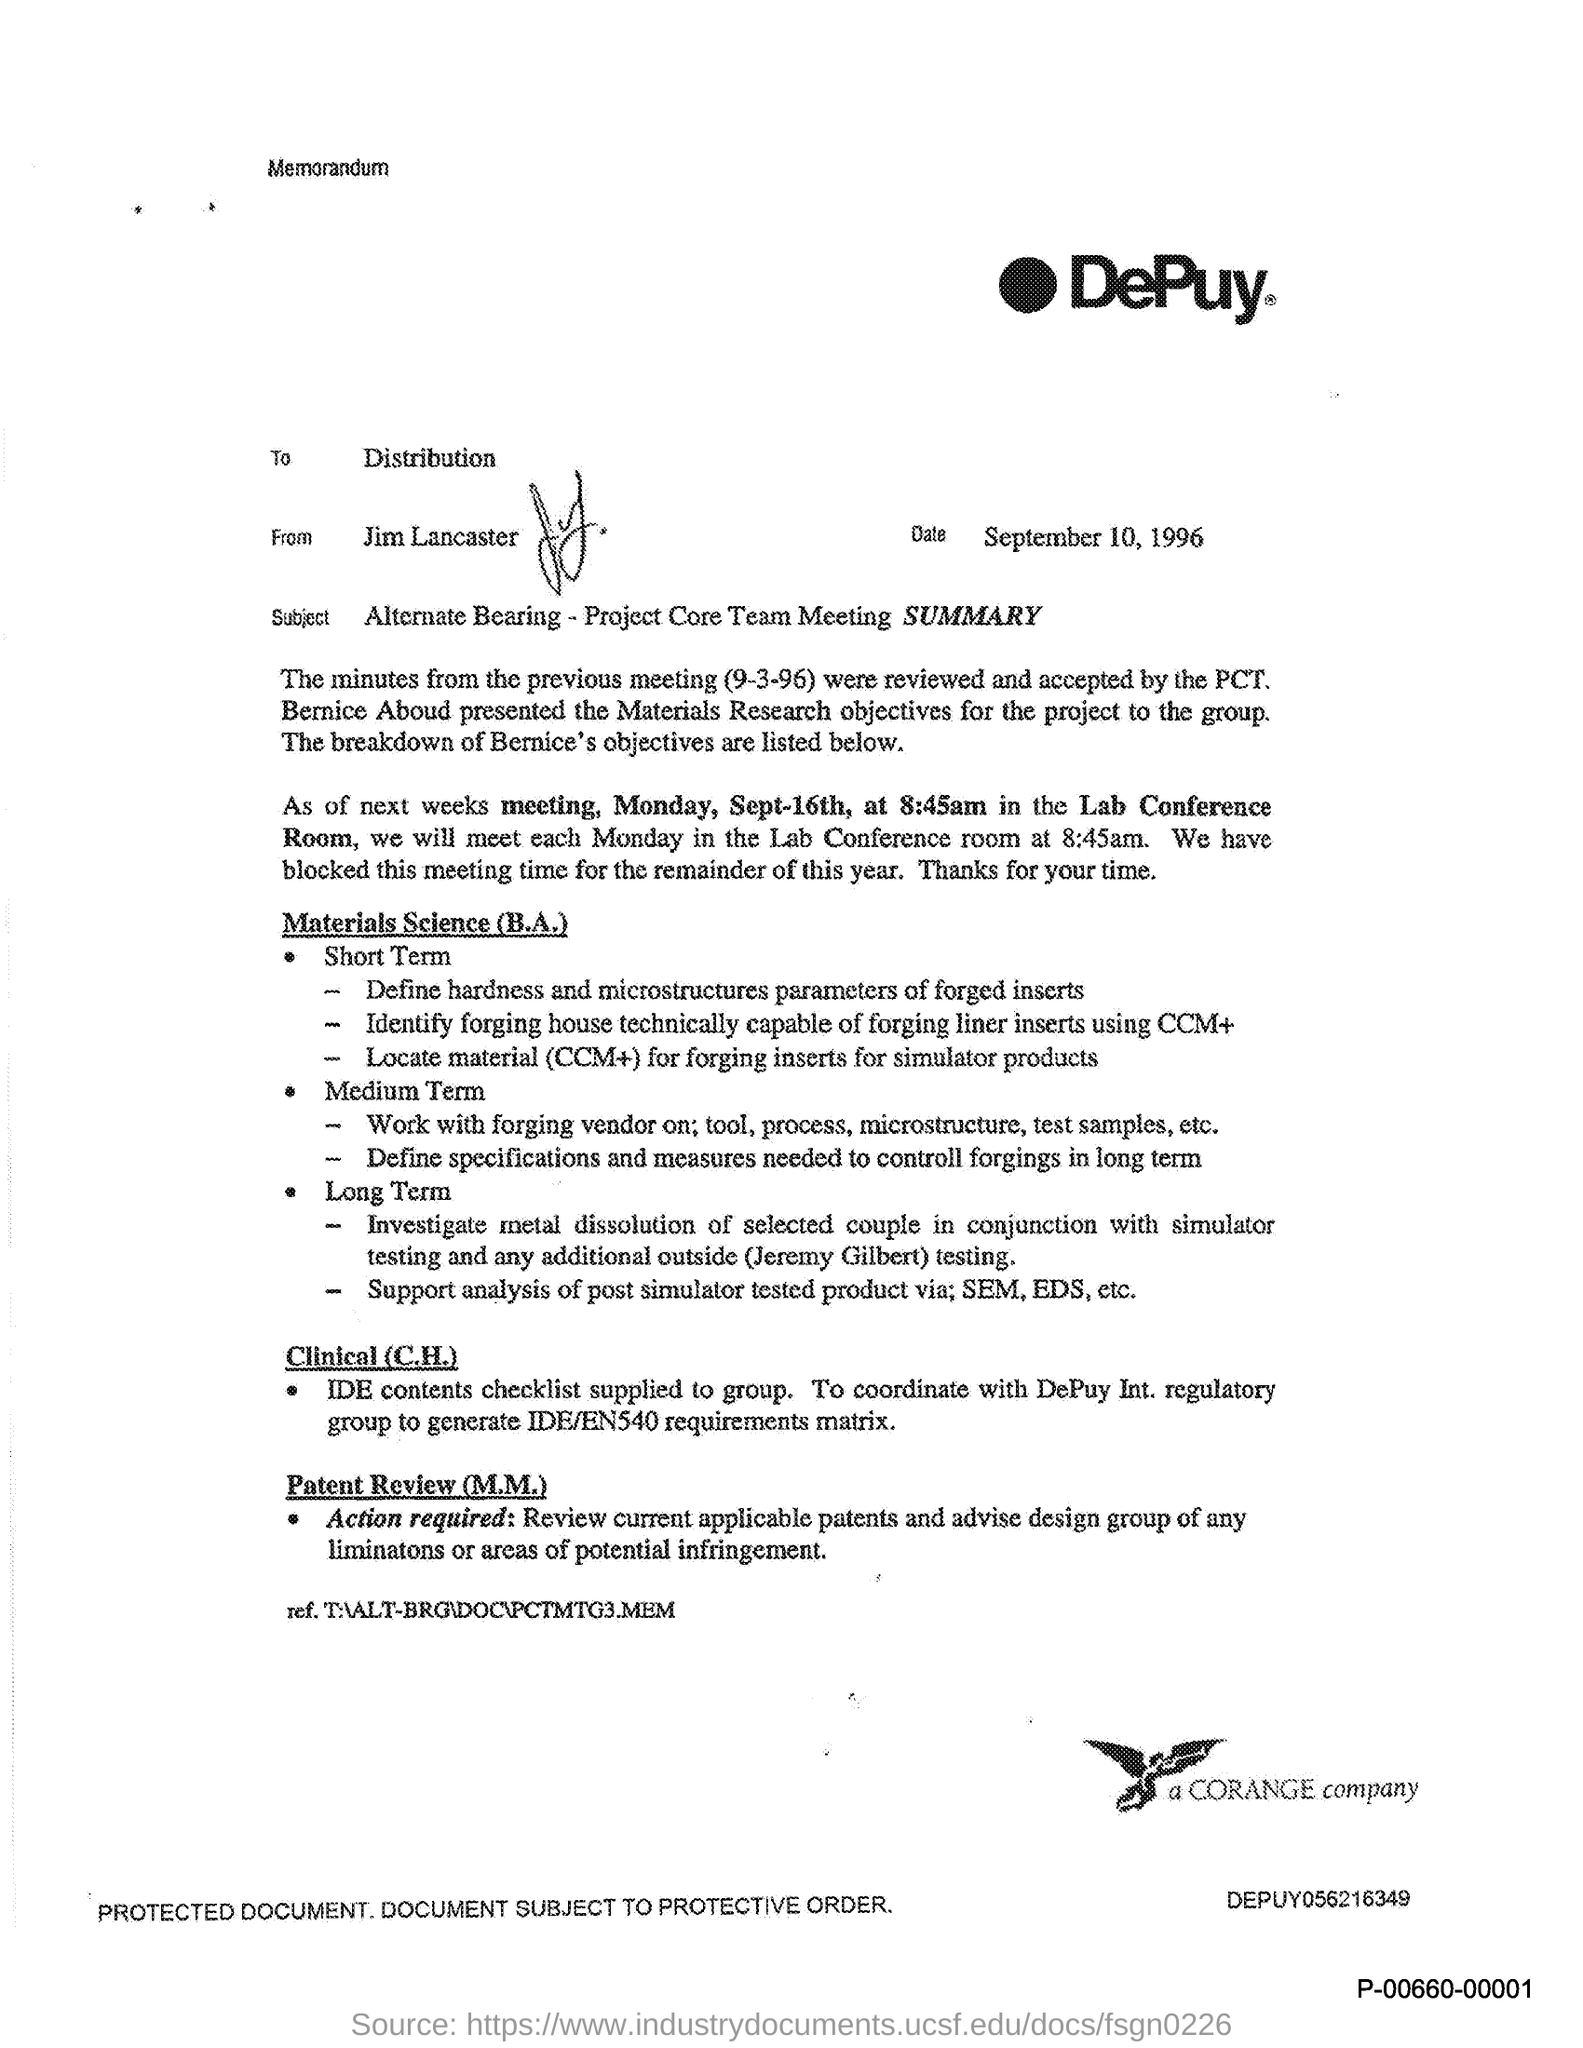To whom is the memorandum addressed?
Your answer should be very brief. Distribution. From whom is the document?
Your answer should be very brief. Jim Lancaster. When is the document dated?
Provide a succinct answer. September 10, 1996. Where will the meeting on Sep-16th be held?
Provide a succinct answer. Lab Conference Room. 